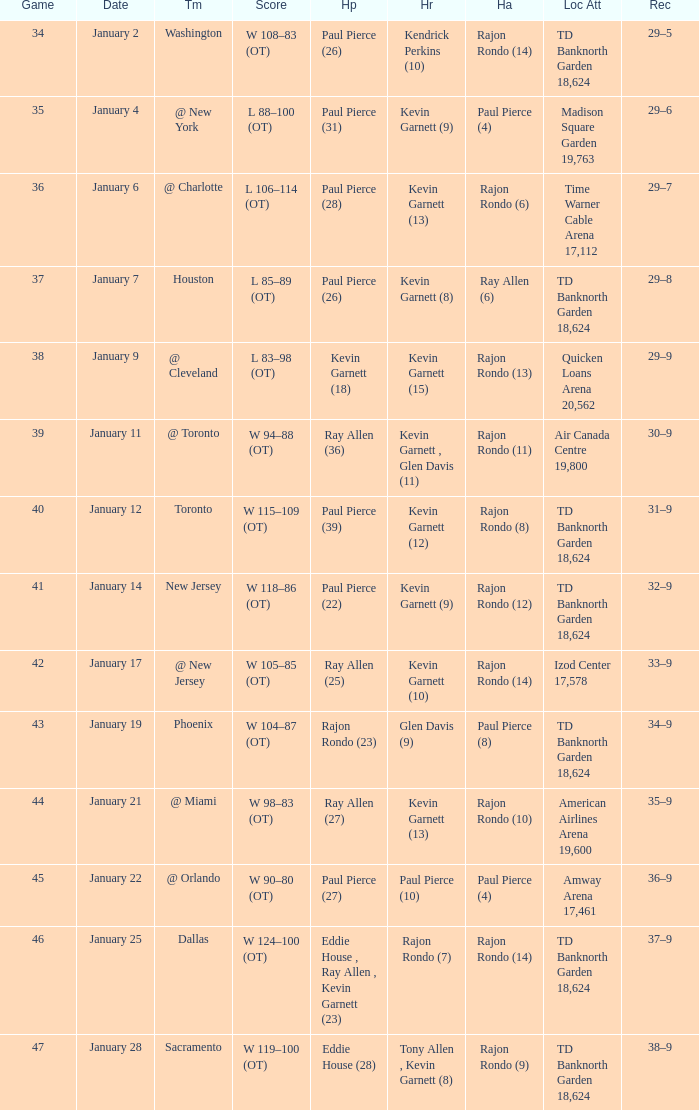Who had the high rebound total on january 6? Kevin Garnett (13). 